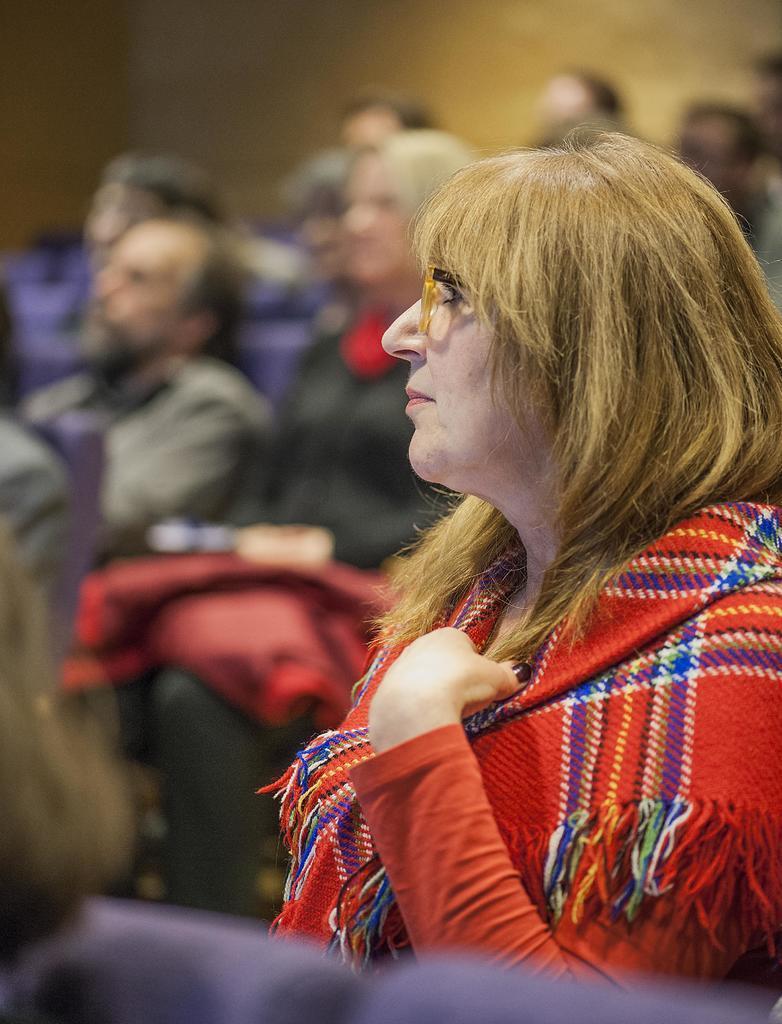How would you summarize this image in a sentence or two? There is a woman sitting and wore spectacle. In the background we can see people and it is blurry. 